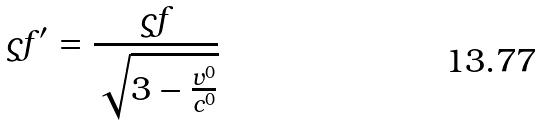Convert formula to latex. <formula><loc_0><loc_0><loc_500><loc_500>\varsigma f ^ { \prime } = \frac { \varsigma f } { \sqrt { 3 - \frac { v ^ { 0 } } { c ^ { 0 } } } }</formula> 